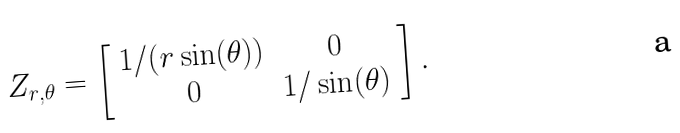<formula> <loc_0><loc_0><loc_500><loc_500>Z _ { r , \theta } = \left [ \begin{array} { c c } 1 / ( r \sin ( \theta ) ) & 0 \\ 0 & 1 / \sin ( \theta ) \end{array} \right ] .</formula> 